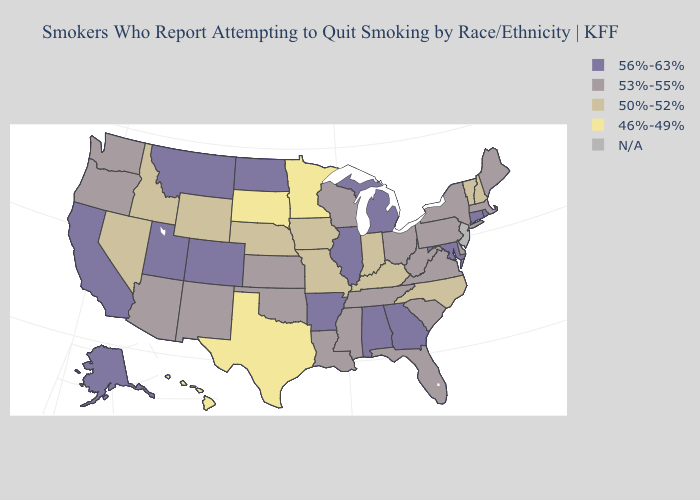What is the value of Ohio?
Answer briefly. 53%-55%. Among the states that border Arizona , which have the lowest value?
Keep it brief. Nevada. What is the lowest value in the Northeast?
Concise answer only. 50%-52%. Among the states that border Washington , does Idaho have the lowest value?
Give a very brief answer. Yes. Name the states that have a value in the range 56%-63%?
Write a very short answer. Alabama, Alaska, Arkansas, California, Colorado, Connecticut, Georgia, Illinois, Maryland, Michigan, Montana, North Dakota, Rhode Island, Utah. Which states have the lowest value in the MidWest?
Keep it brief. Minnesota, South Dakota. What is the lowest value in states that border Iowa?
Short answer required. 46%-49%. Does Illinois have the highest value in the MidWest?
Write a very short answer. Yes. Name the states that have a value in the range 53%-55%?
Concise answer only. Arizona, Delaware, Florida, Kansas, Louisiana, Maine, Massachusetts, Mississippi, New Mexico, New York, Ohio, Oklahoma, Oregon, Pennsylvania, South Carolina, Tennessee, Virginia, Washington, West Virginia, Wisconsin. Does Connecticut have the highest value in the Northeast?
Be succinct. Yes. Which states have the lowest value in the USA?
Concise answer only. Hawaii, Minnesota, South Dakota, Texas. What is the value of Idaho?
Give a very brief answer. 50%-52%. Among the states that border New Hampshire , which have the highest value?
Write a very short answer. Maine, Massachusetts. 